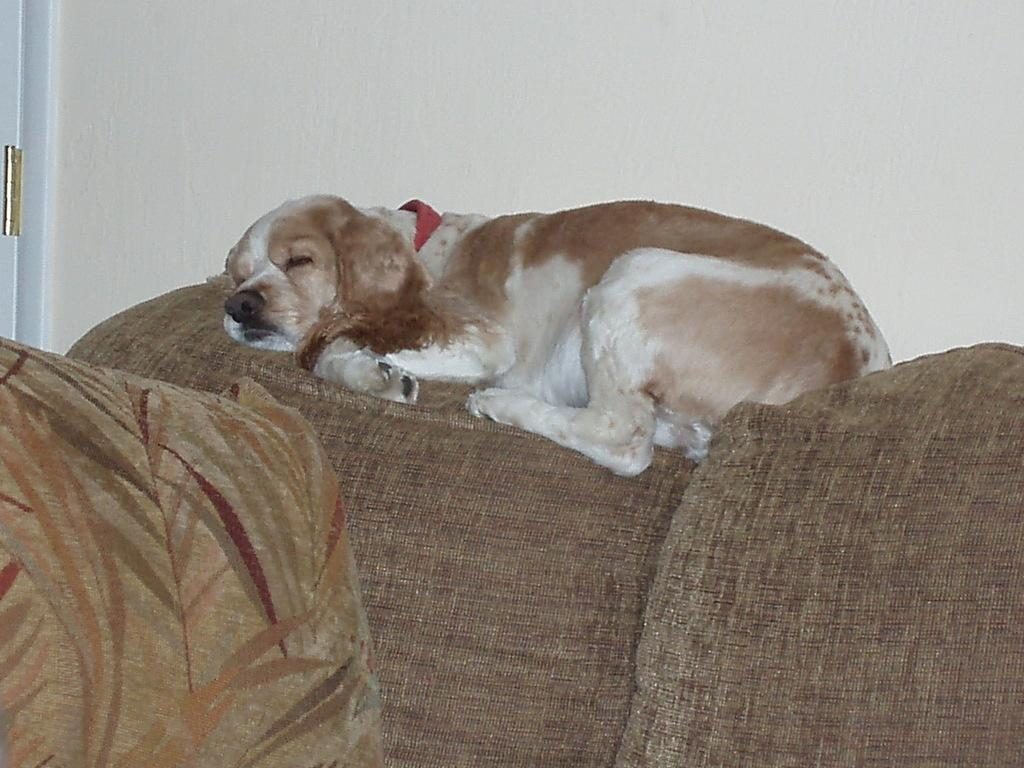What animal can be seen in the image? There is a dog in the image. What is the dog doing in the image? The dog is sleeping on the sofa. What colors can be seen on the dog? The dog is in white and brown color. What is present on the left side of the sofa? There is a pillow on the left side of the sofa. What language is the dog speaking in the image? Dogs do not speak human languages, so there is no language spoken by the dog in the image. 